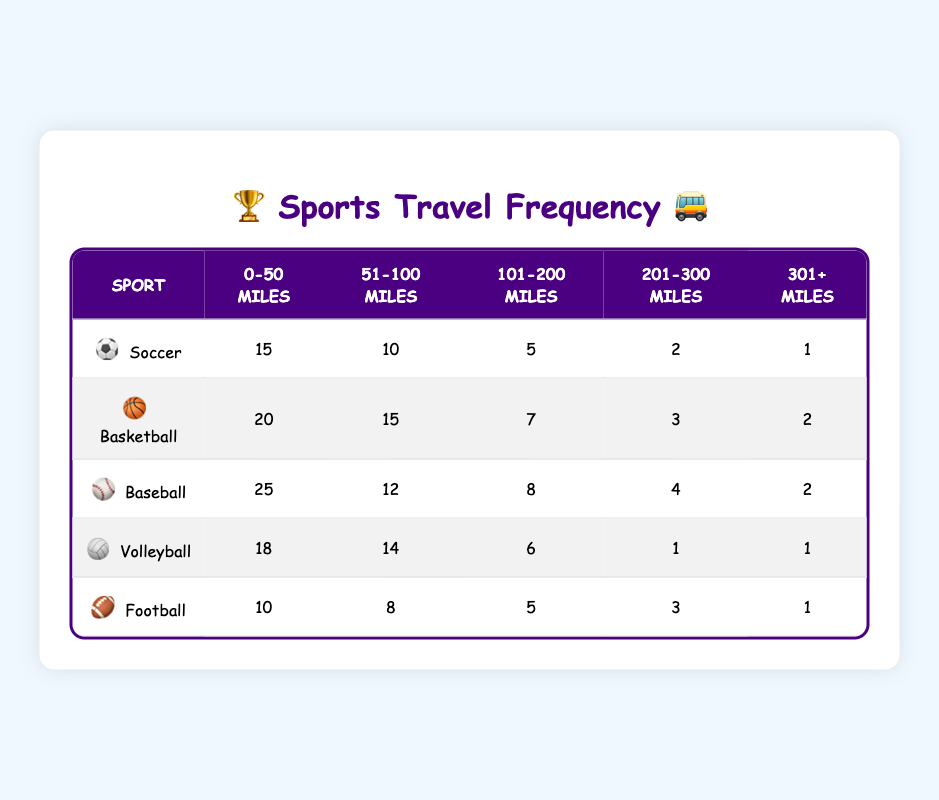What sport has the highest travel frequency in the 0-50 miles range? By looking at the table, we see that Soccer has 15, Basketball has 20, Baseball has 25, Volleyball has 18, and Football has 10. Among these, Baseball has the highest number at 25.
Answer: Baseball How many sports have a travel frequency of 2 or fewer for the 301+ miles range? In the table, for the 301+ miles range, Soccer has 1, Basketball has 2, Baseball has 2, Volleyball has 1, and Football has 1. Counting those with 2 or fewer gives us Soccer (1), Basketball (2), Volleyball (1), and Football (1). Thus, there are 4 sports.
Answer: 4 Which distance range has the lowest total travel frequency across all sports? To find the lowest total, we sum the frequencies for each distance range: 0-50 miles = 15 + 20 + 25 + 18 + 10 = 88, 51-100 miles = 10 + 15 + 12 + 14 + 8 = 59, 101-200 miles = 5 + 7 + 8 + 6 + 5 = 31, 201-300 miles = 2 + 3 + 4 + 1 + 3 = 13, and 301+ miles = 1 + 2 + 2 + 1 + 1 = 7. The lowest is for the 301+ miles range with a total of 7.
Answer: 301+ miles True or False: Volleyball has the highest travel frequency in the 201-300 miles range. In the 201-300 miles range, Soccer has 2, Basketball has 3, Baseball has 4, Volleyball has 1, and Football has 3. The highest is Baseball with a frequency of 4. Therefore, the statement is false.
Answer: False What is the total travel frequency for Basketball across all distance ranges? To find the total for Basketball, we add the frequencies: 20 + 15 + 7 + 3 + 2 = 47. Therefore, the total travel frequency for Basketball is 47.
Answer: 47 